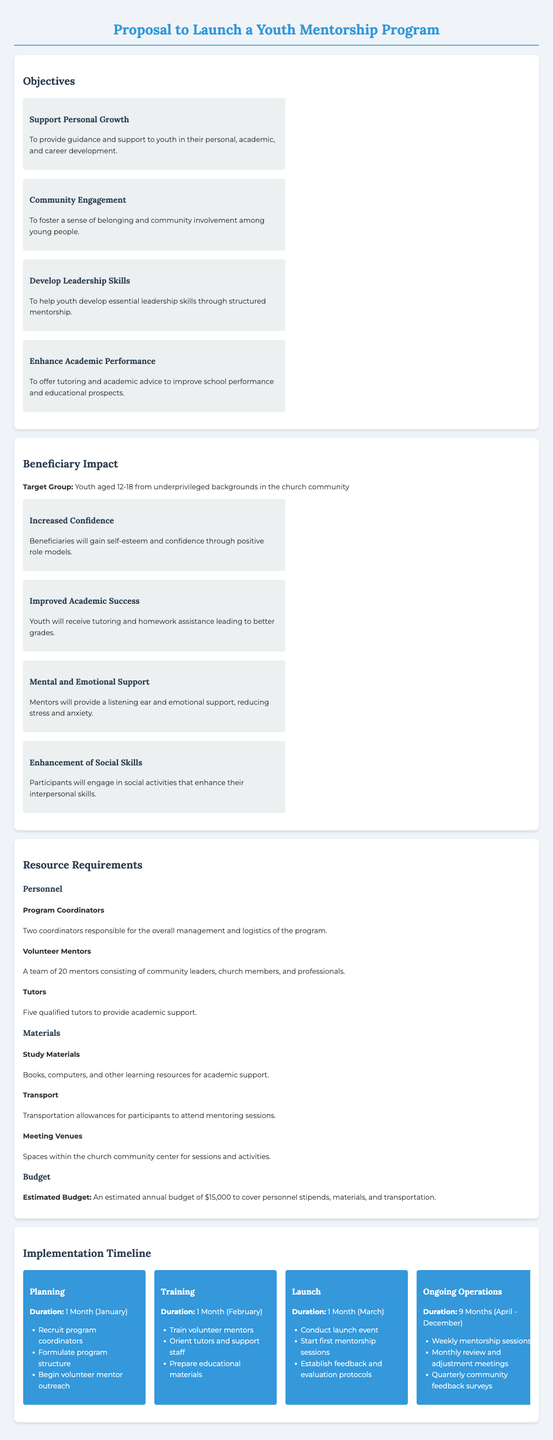what is the target group for the Youth Mentorship Program? The target group is specified in the document as youth aged 12-18 from underprivileged backgrounds in the church community.
Answer: youth aged 12-18 from underprivileged backgrounds how many personnel are required for the program? The personnel section lists three roles that need to be filled: program coordinators, volunteer mentors, and tutors.
Answer: three roles what is the estimated annual budget for the program? The budget is clearly stated in the document as an estimated amount needed to cover personnel, materials, and transportation.
Answer: $15,000 how long will the planning phase last? The duration for the planning phase is given in the implementation timeline section, specifying the time frame involved.
Answer: 1 Month what are the key objectives of the Youth Mentorship Program? The objectives are outlined in the document, highlighting various goals of the program.
Answer: Support Personal Growth, Community Engagement, Develop Leadership Skills, Enhance Academic Performance which month is the launch event scheduled? The launch event's timing is indicated under the launch phase in the implementation timeline, detailing when this event will occur.
Answer: March how many volunteer mentors are planned for the program? The document specifies the number of volunteer mentors required for effective operation of the mentoring program.
Answer: 20 mentors what will be included in the ongoing operations phase? The ongoing operations phase details the activities planned during this phase of the program, which can be identified in the timeline.
Answer: Weekly mentorship sessions, Monthly review and adjustment meetings, Quarterly community feedback surveys what aspect of personal development does the program aim to support? The objectives highlight this aspect, focusing on various developmental goals for the youth.
Answer: personal, academic, and career development 